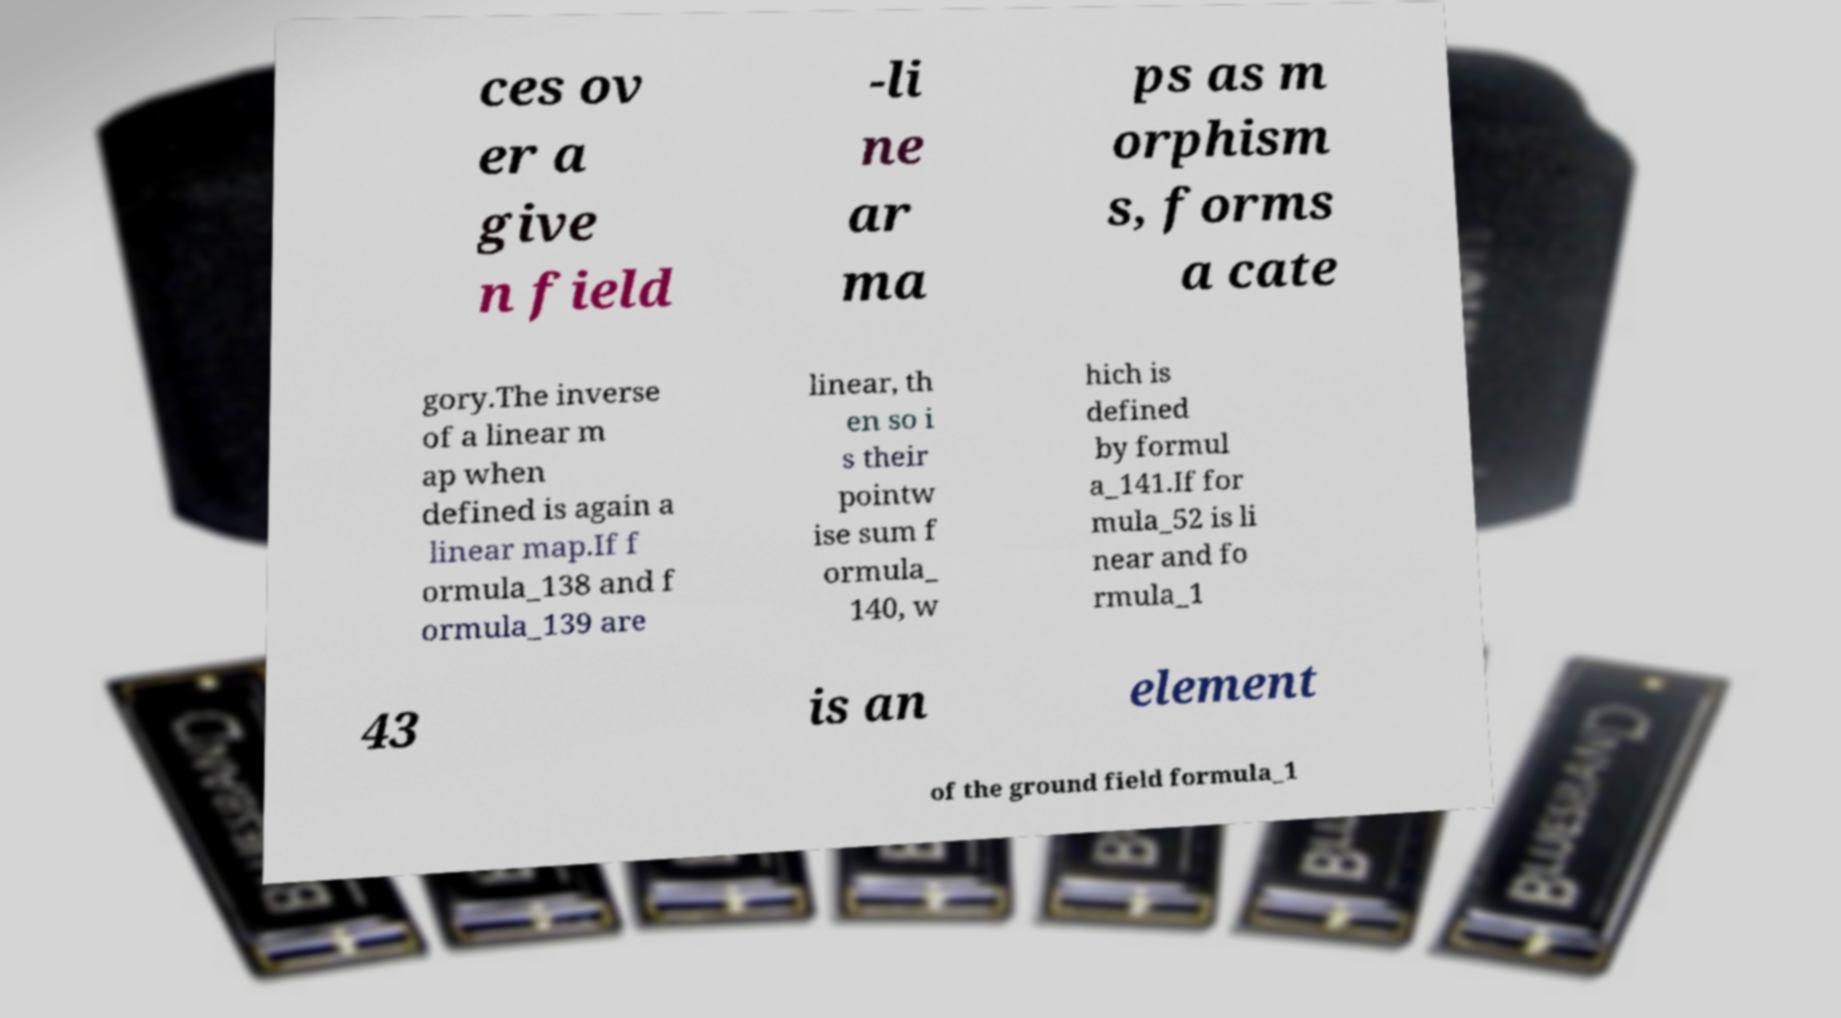Can you read and provide the text displayed in the image?This photo seems to have some interesting text. Can you extract and type it out for me? ces ov er a give n field -li ne ar ma ps as m orphism s, forms a cate gory.The inverse of a linear m ap when defined is again a linear map.If f ormula_138 and f ormula_139 are linear, th en so i s their pointw ise sum f ormula_ 140, w hich is defined by formul a_141.If for mula_52 is li near and fo rmula_1 43 is an element of the ground field formula_1 